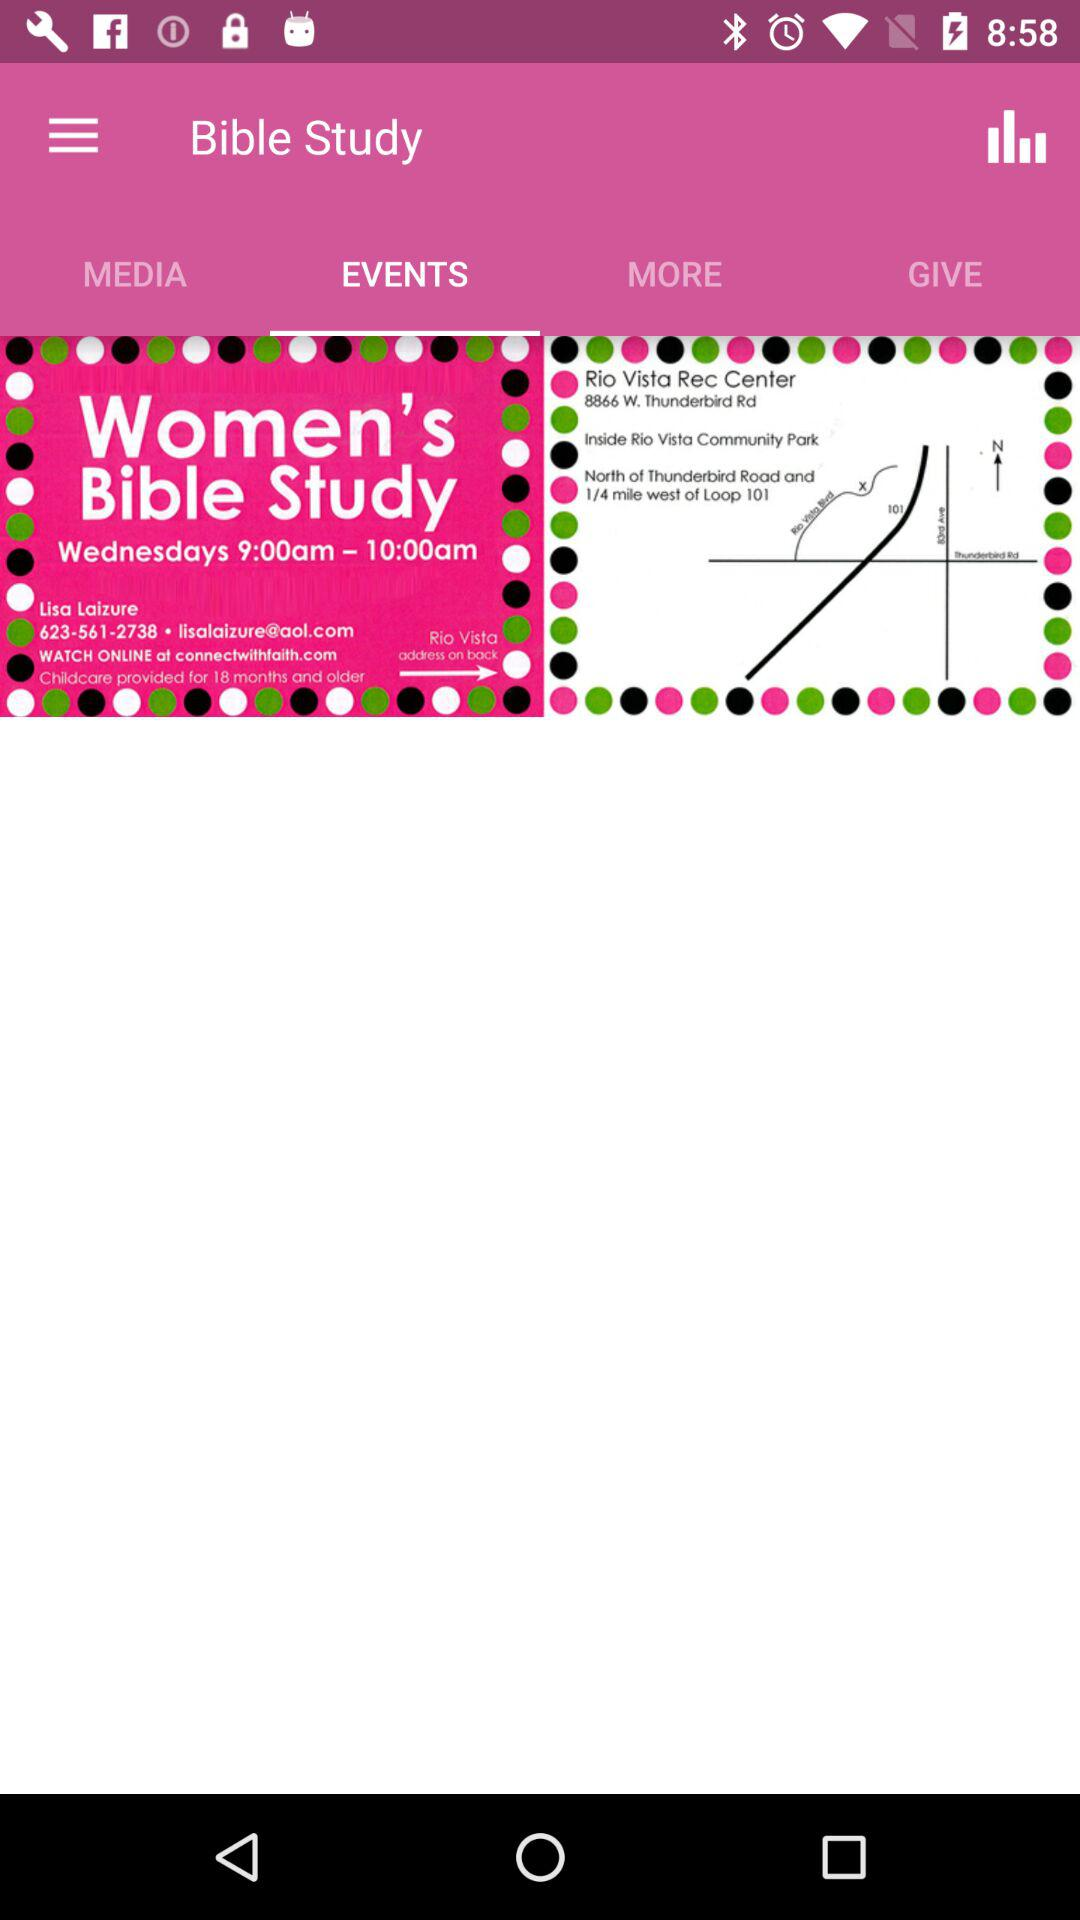What is the Time for Women's Bible Study? The time is from 9:00 AM to 10:00 AM. 